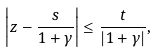Convert formula to latex. <formula><loc_0><loc_0><loc_500><loc_500>\left | z - \frac { s } { 1 + \gamma } \right | \leq \frac { t } { | 1 + \gamma | } ,</formula> 